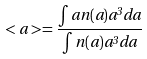Convert formula to latex. <formula><loc_0><loc_0><loc_500><loc_500>< a > = \frac { \int a n ( a ) a ^ { 3 } d a } { \int n ( a ) a ^ { 3 } d a }</formula> 